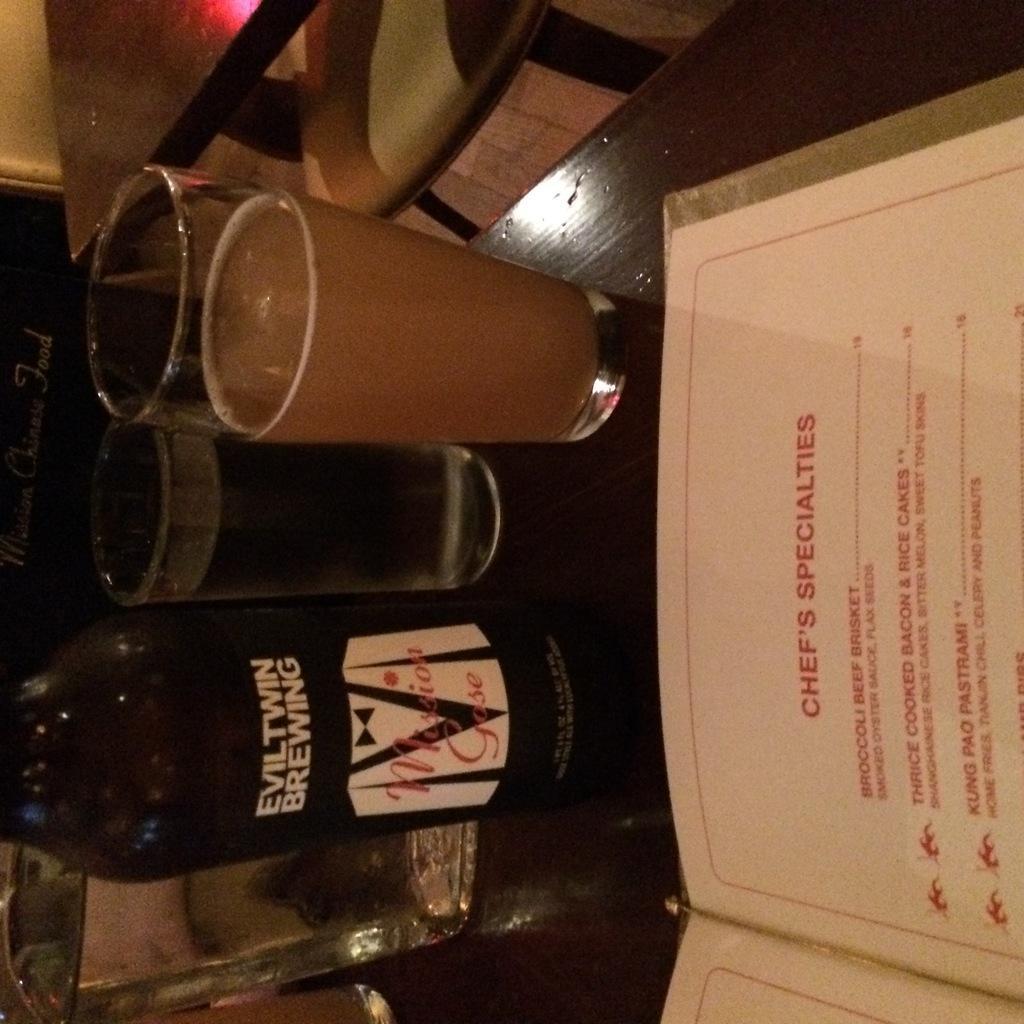Could you give a brief overview of what you see in this image? In this picture we can see a table, there are three glasses of drinks, two bottles and a menu card present on the table, we can see another table at the top of the picture. 